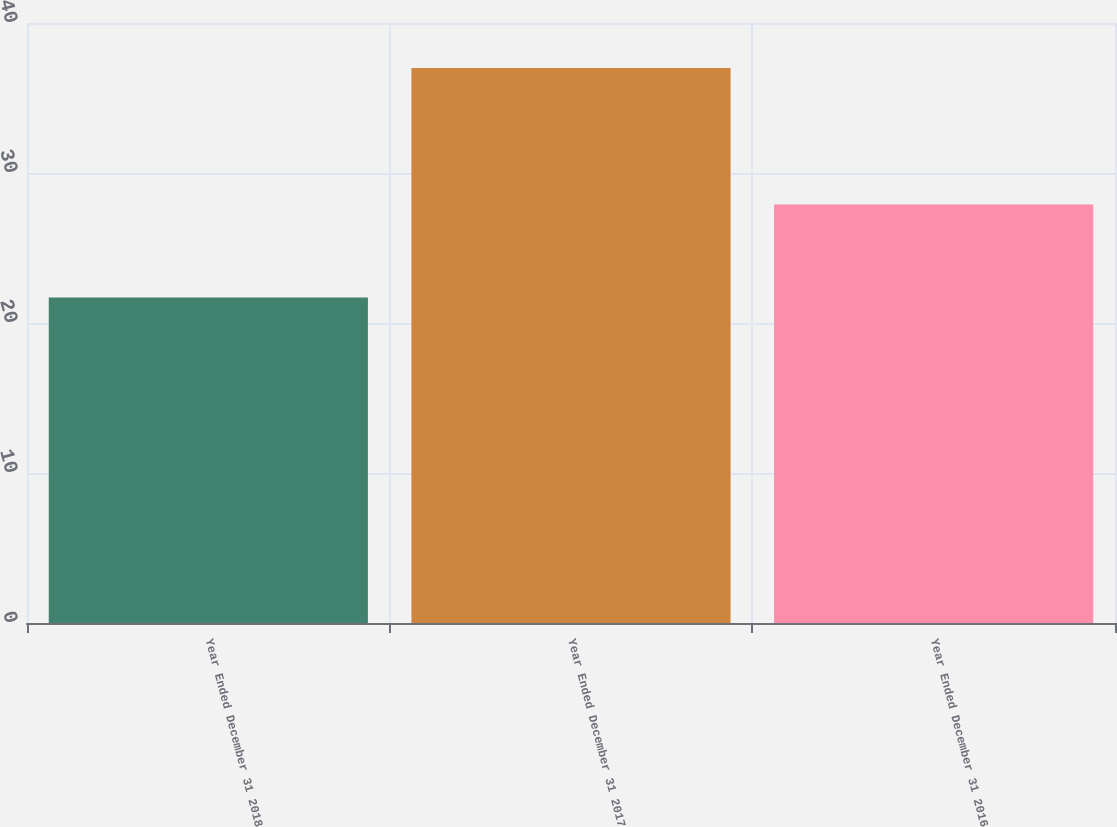Convert chart. <chart><loc_0><loc_0><loc_500><loc_500><bar_chart><fcel>Year Ended December 31 2018<fcel>Year Ended December 31 2017<fcel>Year Ended December 31 2016<nl><fcel>21.7<fcel>37<fcel>27.9<nl></chart> 